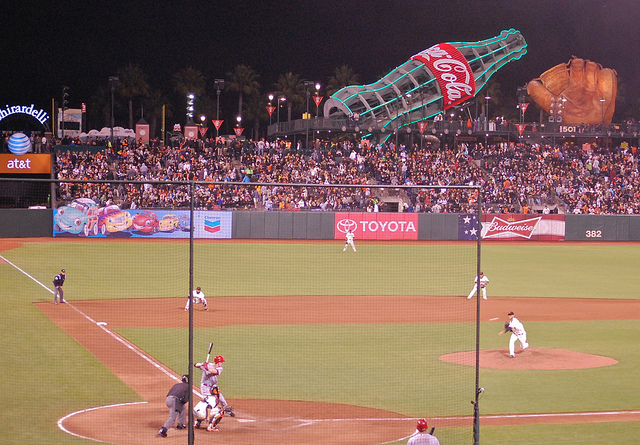Identify the text contained in this image. hirardelli at&amp;t TOYOTA 1501 382 CoCo Cola 